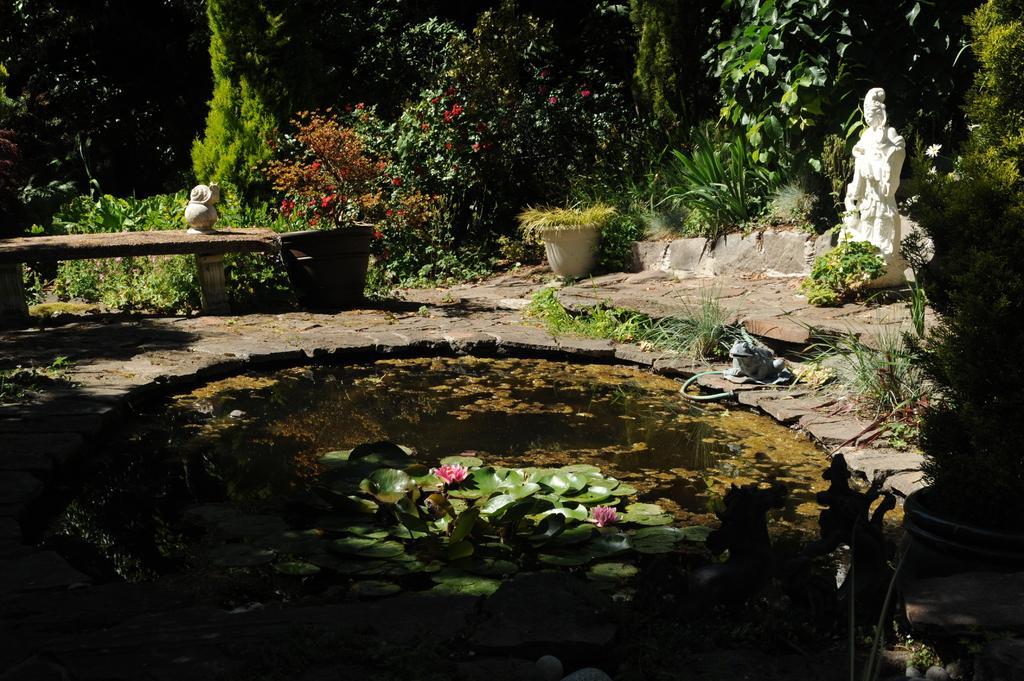How would you summarize this image in a sentence or two? In this picture I can observe a small pond. There are lotus flowers in this pond. On the right side I can observe a statue which is in white color. In the background I can observe some plants and trees. On the left side I can observe a bench. 